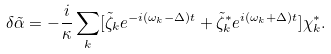Convert formula to latex. <formula><loc_0><loc_0><loc_500><loc_500>\delta \tilde { \alpha } = - \frac { i } { \kappa } \sum _ { k } [ \tilde { \zeta } _ { k } e ^ { - i ( \omega _ { k } - \Delta ) t } + \tilde { \zeta } _ { k } ^ { * } e ^ { i ( \omega _ { k } + \Delta ) t } ] \chi _ { k } ^ { * } .</formula> 